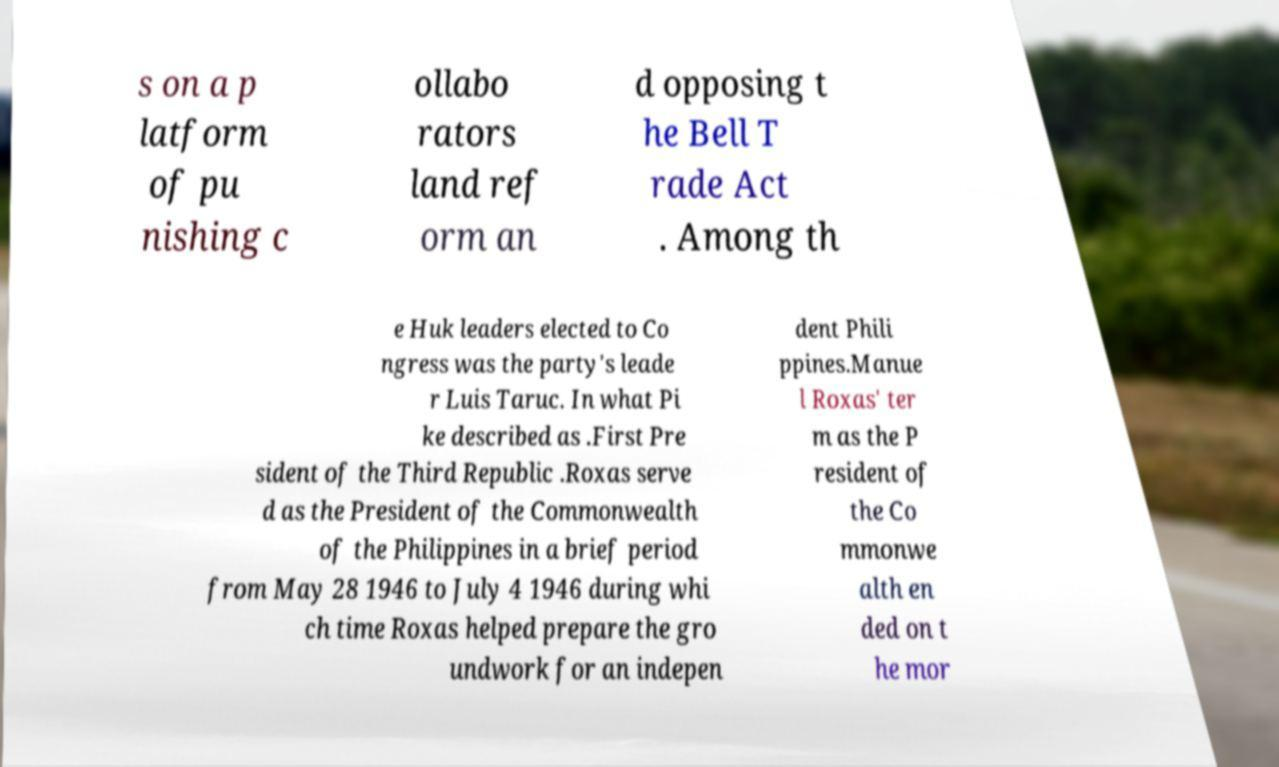Can you read and provide the text displayed in the image?This photo seems to have some interesting text. Can you extract and type it out for me? s on a p latform of pu nishing c ollabo rators land ref orm an d opposing t he Bell T rade Act . Among th e Huk leaders elected to Co ngress was the party's leade r Luis Taruc. In what Pi ke described as .First Pre sident of the Third Republic .Roxas serve d as the President of the Commonwealth of the Philippines in a brief period from May 28 1946 to July 4 1946 during whi ch time Roxas helped prepare the gro undwork for an indepen dent Phili ppines.Manue l Roxas' ter m as the P resident of the Co mmonwe alth en ded on t he mor 